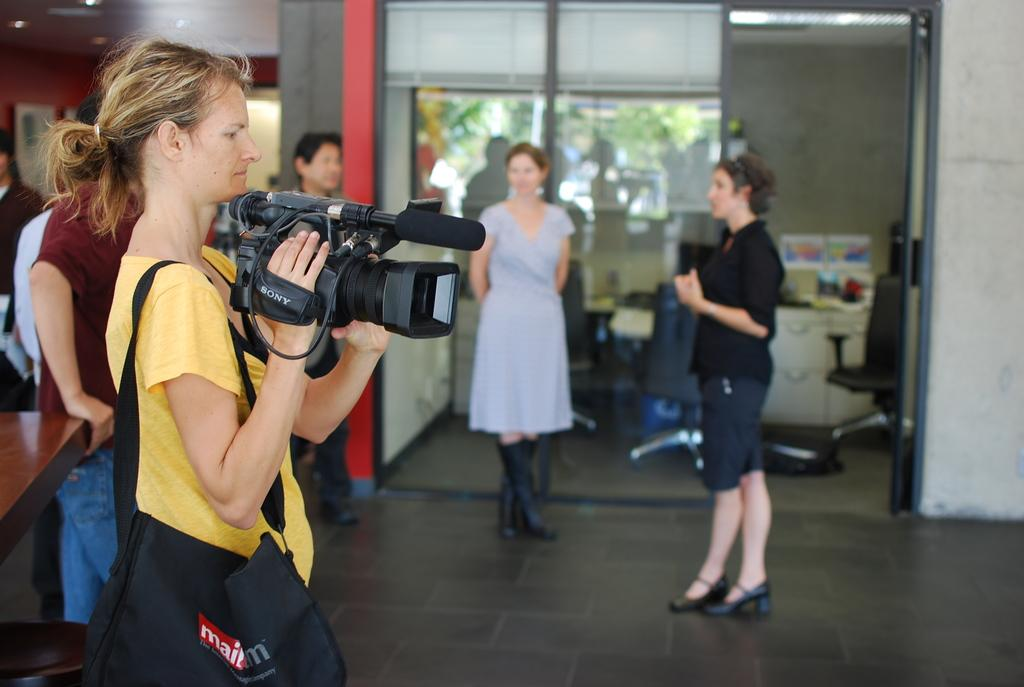Who is the main subject in the image? There is a woman in the image. What is the woman holding in the image? The woman is holding a camera. What is the woman wearing in the image? The woman is wearing a bag. What can be seen in the background of the image? There are people standing, a desk, a chair, and a tree in the background of the image. What type of recess is visible in the image? There is no recess present in the image. What is the value of the cent in the image? There is no cent present in the image. 